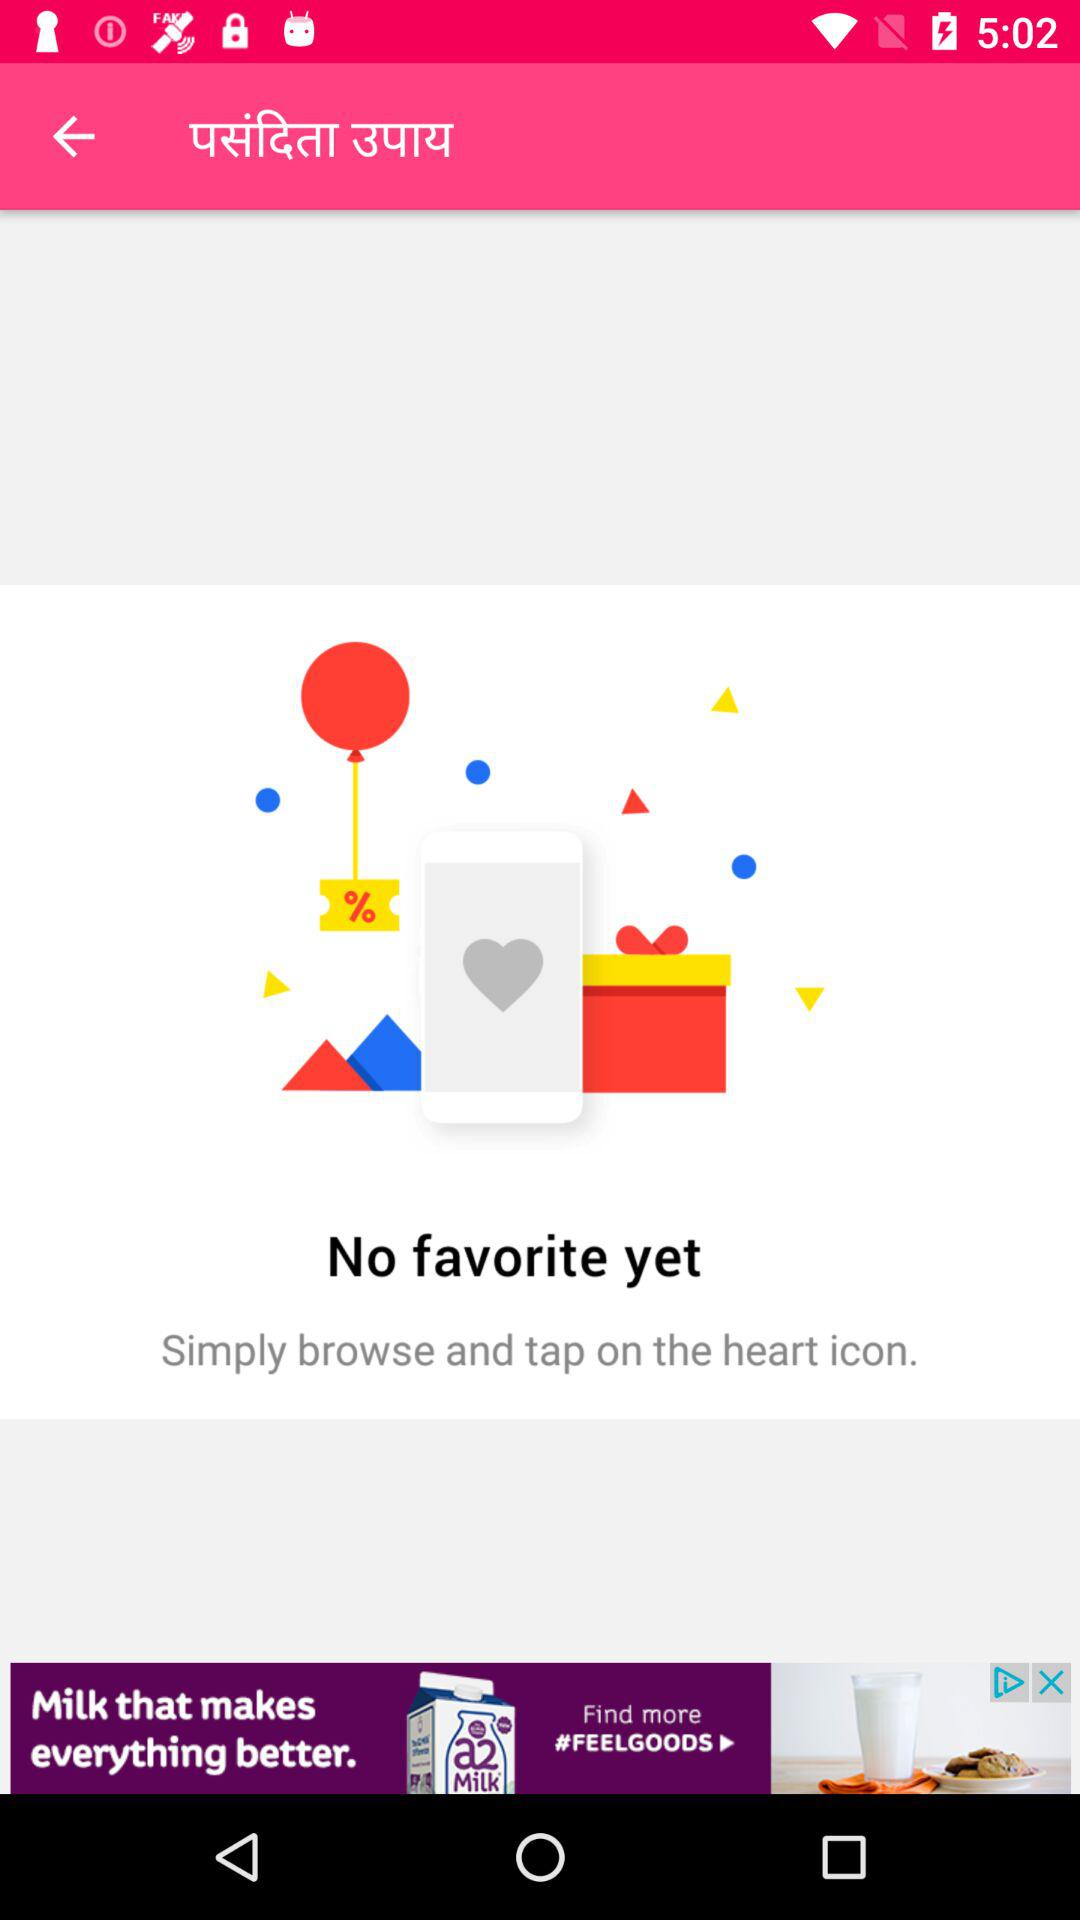What is the name of the application?
When the provided information is insufficient, respond with <no answer>. <no answer> 